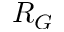Convert formula to latex. <formula><loc_0><loc_0><loc_500><loc_500>R _ { G }</formula> 